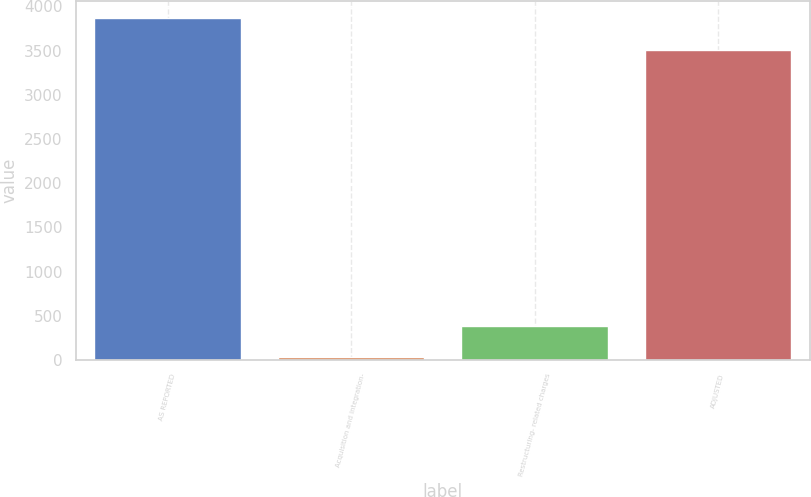<chart> <loc_0><loc_0><loc_500><loc_500><bar_chart><fcel>AS REPORTED<fcel>Acquisition and integration-<fcel>Restructuring- related charges<fcel>ADJUSTED<nl><fcel>3868.2<fcel>28<fcel>386.2<fcel>3510<nl></chart> 